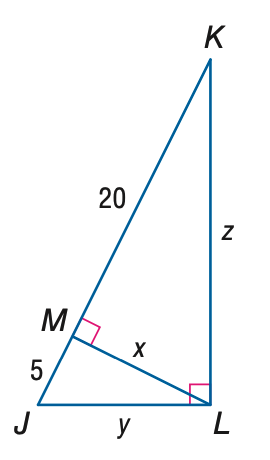Answer the mathemtical geometry problem and directly provide the correct option letter.
Question: Find z.
Choices: A: 10 B: 10 \sqrt { 3 } C: 20 D: 10 \sqrt { 5 } D 